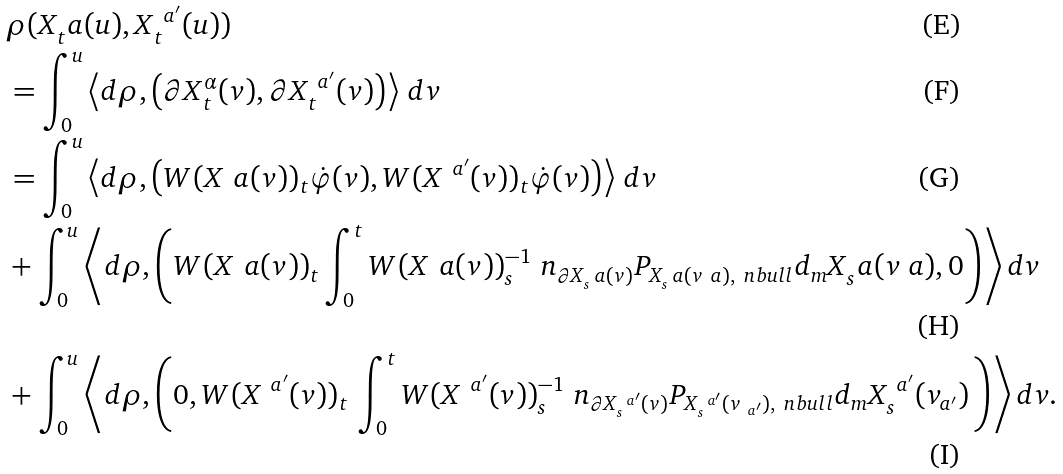<formula> <loc_0><loc_0><loc_500><loc_500>& \rho ( X _ { t } ^ { \ } a ( u ) , X _ { t } ^ { \ a ^ { \prime } } ( u ) ) \\ & = \int _ { 0 } ^ { u } \left \langle d \rho , \left ( \partial X _ { t } ^ { \alpha } ( v ) , \partial X _ { t } ^ { \ a ^ { \prime } } ( v ) \right ) \right \rangle \, d v \\ & = \int _ { 0 } ^ { u } \left \langle d \rho , \left ( W ( X ^ { \ } a ( v ) ) _ { t } \dot { \varphi } ( v ) , W ( X ^ { \ a ^ { \prime } } ( v ) ) _ { t } \dot { \varphi } ( v ) \right ) \right \rangle \, d v \\ & + \int _ { 0 } ^ { u } \left \langle d \rho , \left ( W ( X ^ { \ } a ( v ) ) _ { t } \int _ { 0 } ^ { t } W ( X ^ { \ } a ( v ) ) _ { s } ^ { - 1 } \ n _ { \partial X _ { s } ^ { \ } a ( v ) } P _ { X _ { s } ^ { \ } a ( v _ { \ } a ) , \ n b u l l } d _ { m } X _ { s } ^ { \ } a ( v _ { \ } a ) , 0 \right ) \right \rangle d v \\ & + \int _ { 0 } ^ { u } \left \langle d \rho , \left ( 0 , W ( X ^ { \ a ^ { \prime } } ( v ) ) _ { t } \, \int _ { 0 } ^ { t } W ( X ^ { \ a ^ { \prime } } ( v ) ) _ { s } ^ { - 1 } \ n _ { \partial X _ { s } ^ { \ a ^ { \prime } } ( v ) } P _ { X _ { s } ^ { \ a ^ { \prime } } ( v _ { \ a ^ { \prime } } ) , \ n b u l l } d _ { m } X _ { s } ^ { \ a ^ { \prime } } ( v _ { a ^ { \prime } } ) \, \right ) \right \rangle d v .</formula> 